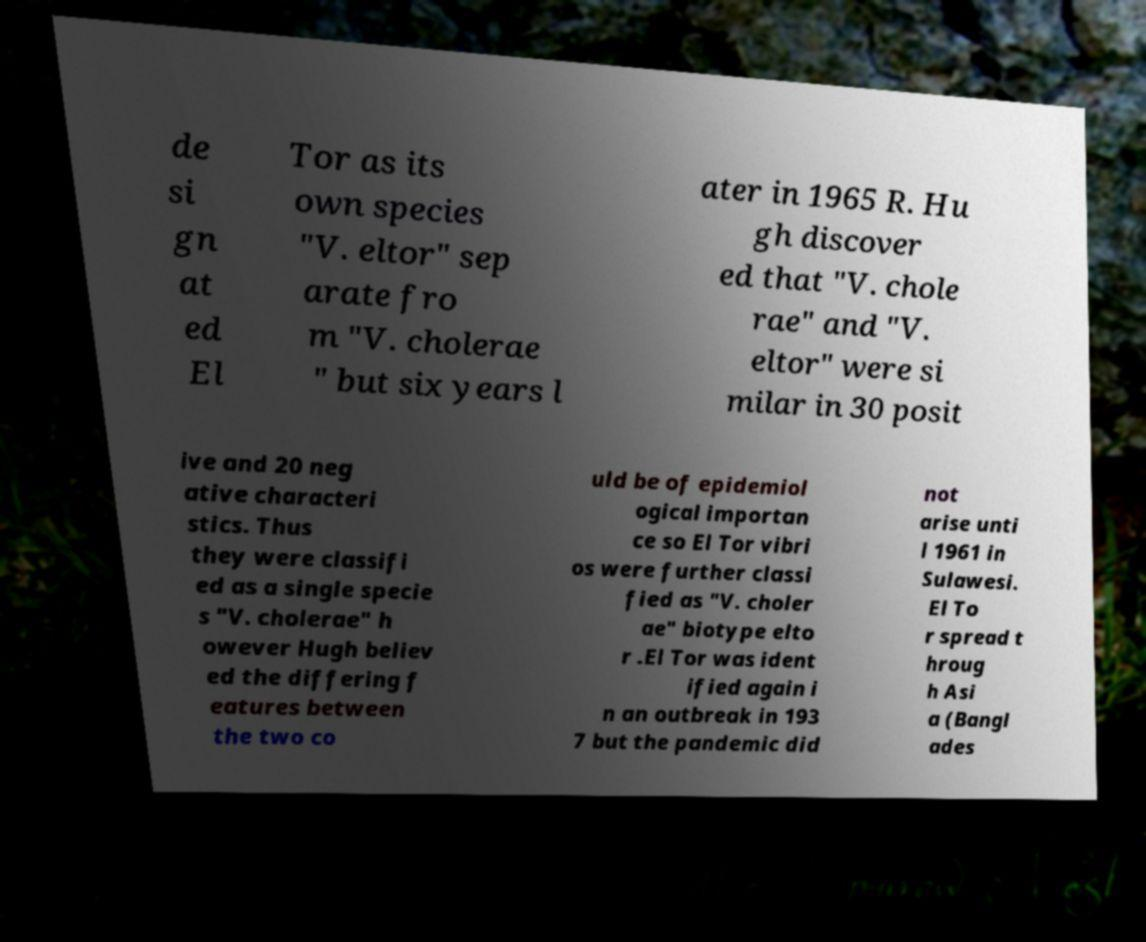For documentation purposes, I need the text within this image transcribed. Could you provide that? de si gn at ed El Tor as its own species "V. eltor" sep arate fro m "V. cholerae " but six years l ater in 1965 R. Hu gh discover ed that "V. chole rae" and "V. eltor" were si milar in 30 posit ive and 20 neg ative characteri stics. Thus they were classifi ed as a single specie s "V. cholerae" h owever Hugh believ ed the differing f eatures between the two co uld be of epidemiol ogical importan ce so El Tor vibri os were further classi fied as "V. choler ae" biotype elto r .El Tor was ident ified again i n an outbreak in 193 7 but the pandemic did not arise unti l 1961 in Sulawesi. El To r spread t hroug h Asi a (Bangl ades 